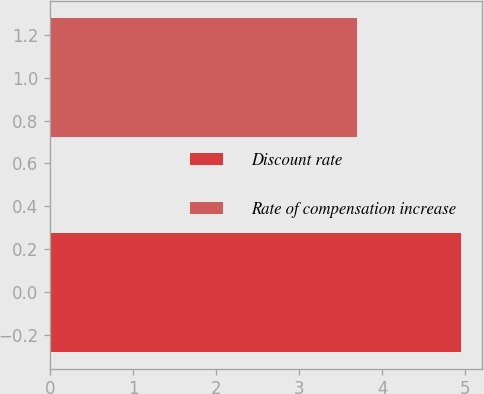Convert chart to OTSL. <chart><loc_0><loc_0><loc_500><loc_500><bar_chart><fcel>Discount rate<fcel>Rate of compensation increase<nl><fcel>4.95<fcel>3.7<nl></chart> 